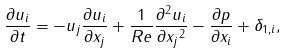Convert formula to latex. <formula><loc_0><loc_0><loc_500><loc_500>\frac { \partial { u _ { i } } } { \partial { t } } = - u _ { j } \frac { \partial { u _ { i } } } { \partial { x _ { j } } } + \frac { 1 } { R e } \frac { \partial ^ { 2 } { u _ { i } } } { \partial { x _ { j } } ^ { 2 } } - \frac { \partial { p } } { \partial { x _ { i } } } + \delta _ { 1 , i } ,</formula> 